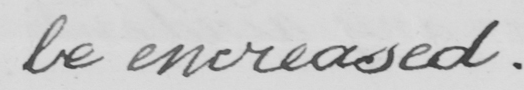What text is written in this handwritten line? be increased . 